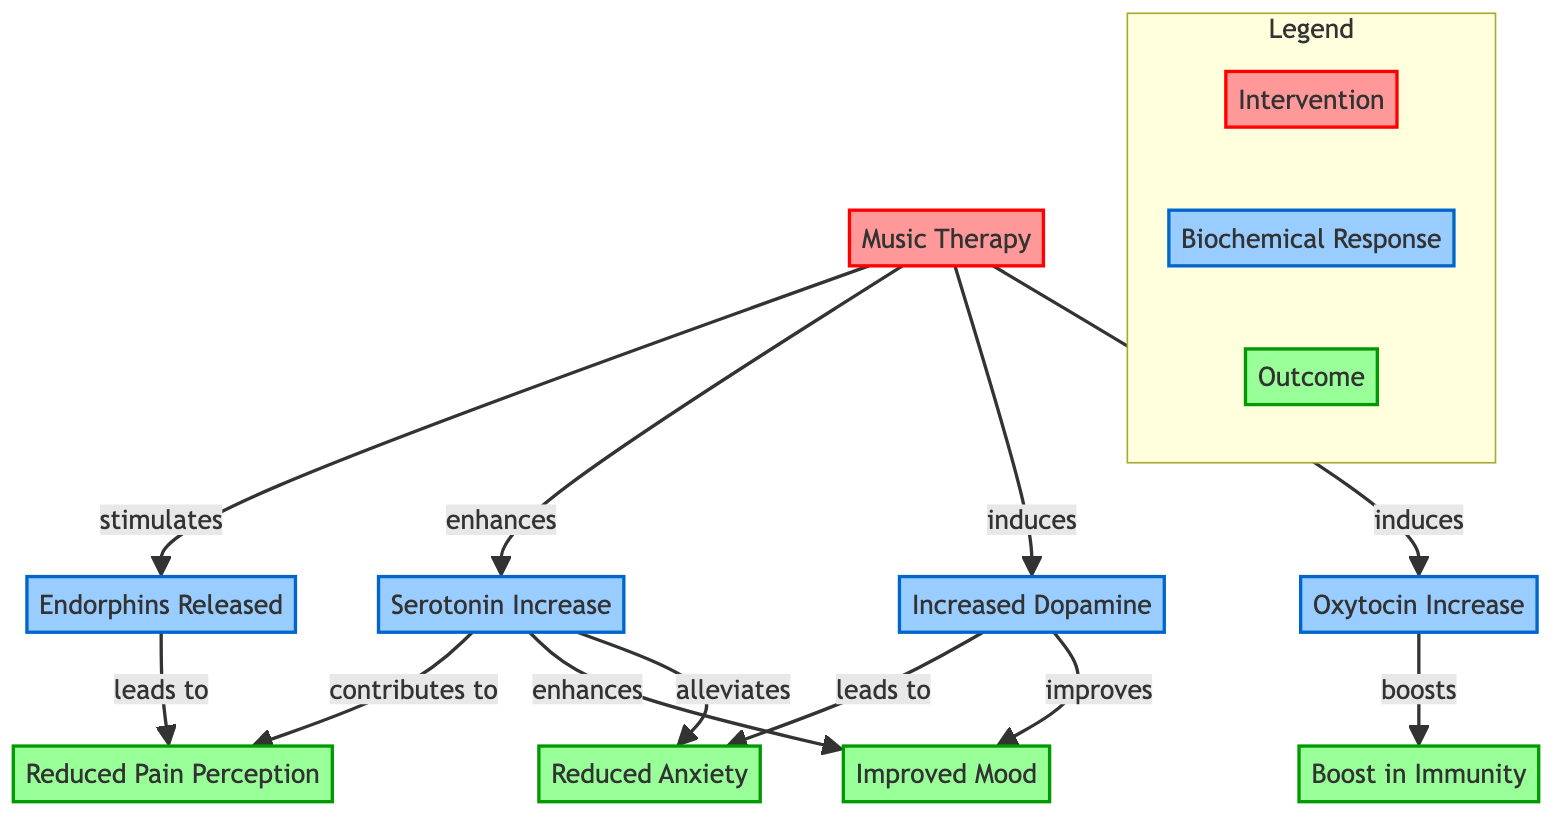What is the main intervention depicted in the diagram? The diagram identifies "Music Therapy" as the main intervention, which is noted prominently at the start of the flowchart.
Answer: Music Therapy How many biochemical responses are shown in the diagram? The diagram lists four biochemical responses: Endorphins Released, Serotonin Increase, Increased Dopamine, and Oxytocin Increase. Counting these nodes reveals a total of four.
Answer: 4 What outcome is directly affected by the release of endorphins? The diagram indicates that the release of endorphins leads to a reduction in pain perception, establishing a direct connection.
Answer: Reduced Pain Perception Which neurotransmitter is linked to both reducing anxiety and improving mood? The diagram shows that Serotonin is involved in reducing anxiety and enhances mood, indicating it plays a role in both outcomes.
Answer: Serotonin How does music therapy affect immunity according to the diagram? The diagram indicates that the release of Oxytocin, induced by music therapy, boosts immunity, establishing a clear connection between the intervention and this outcome.
Answer: Boosts What combination of biochemical responses contributes to reduced anxiety? The diagram outlines that both Increased Dopamine and Serotonin Increase contribute to the reduction of anxiety, indicating a combination of these two factors.
Answer: Increased Dopamine and Serotonin Increase What is the flow direction for the effect of music therapy on improved mood? The diagram shows that Music Therapy enhances Serotonin and this increase in Serotonin leads to an improved mood, establishing this directional relationship.
Answer: Enhances Serotonin Which outcome is affected by both Increased Dopamine and Serotonin? According to the diagram, both Increased Dopamine and Serotonin Increase have paths that lead to Improved Mood, indicating their joint contribution to this outcome.
Answer: Improved Mood What is a common feature of all outcomes listed in the diagram? Each outcome in the diagram relates to some form of improvement or reduction, such as reduced pain perception, reduced anxiety, improved mood, and a boost in immunity, which share a common objective of enhancing well-being.
Answer: Improvement 